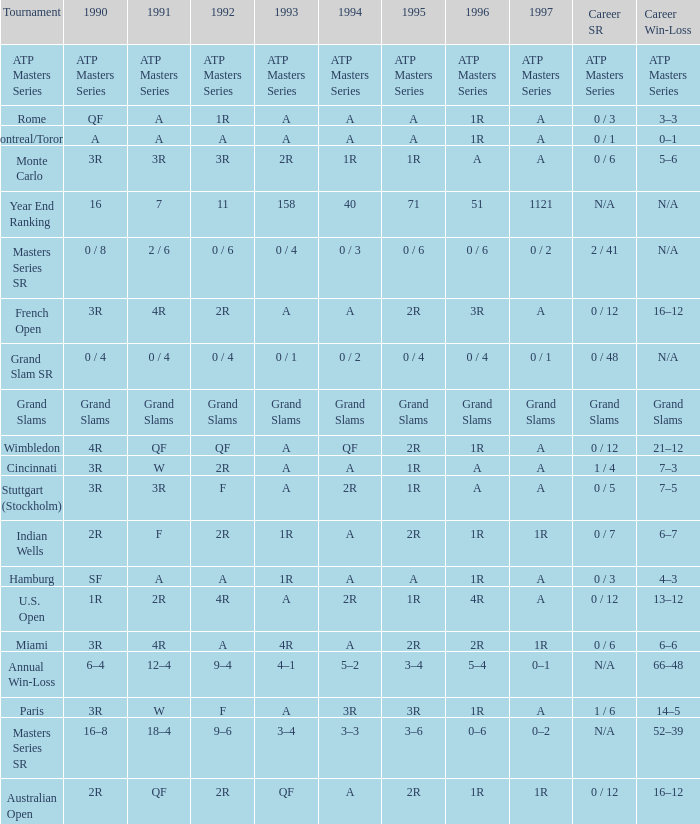What is 1996, when 1992 is "ATP Masters Series"? ATP Masters Series. 